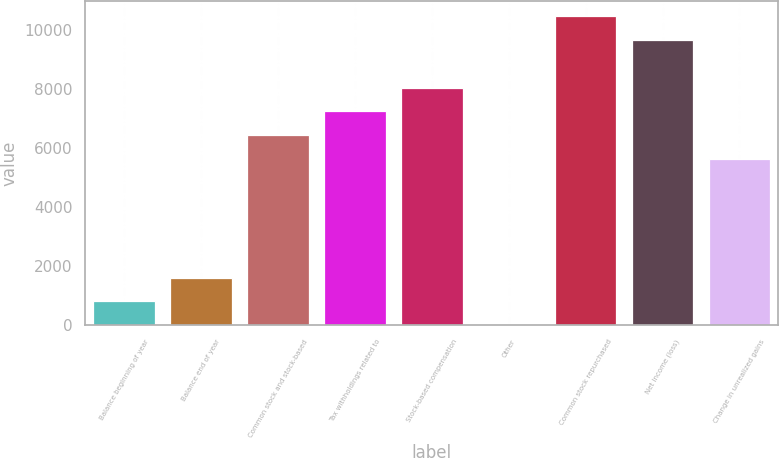<chart> <loc_0><loc_0><loc_500><loc_500><bar_chart><fcel>Balance beginning of year<fcel>Balance end of year<fcel>Common stock and stock-based<fcel>Tax withholdings related to<fcel>Stock-based compensation<fcel>Other<fcel>Common stock repurchased<fcel>Net income (loss)<fcel>Change in unrealized gains<nl><fcel>805.8<fcel>1610.6<fcel>6439.4<fcel>7244.2<fcel>8049<fcel>1<fcel>10463.4<fcel>9658.6<fcel>5634.6<nl></chart> 